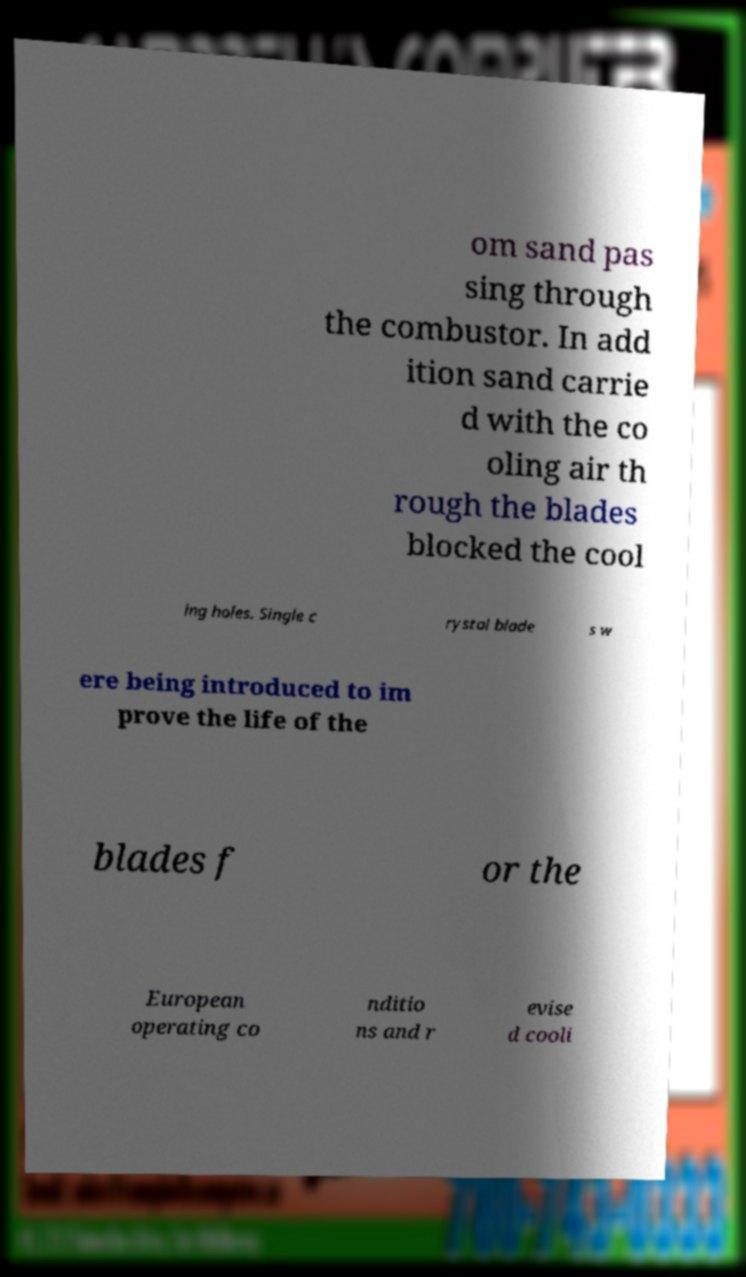What messages or text are displayed in this image? I need them in a readable, typed format. om sand pas sing through the combustor. In add ition sand carrie d with the co oling air th rough the blades blocked the cool ing holes. Single c rystal blade s w ere being introduced to im prove the life of the blades f or the European operating co nditio ns and r evise d cooli 